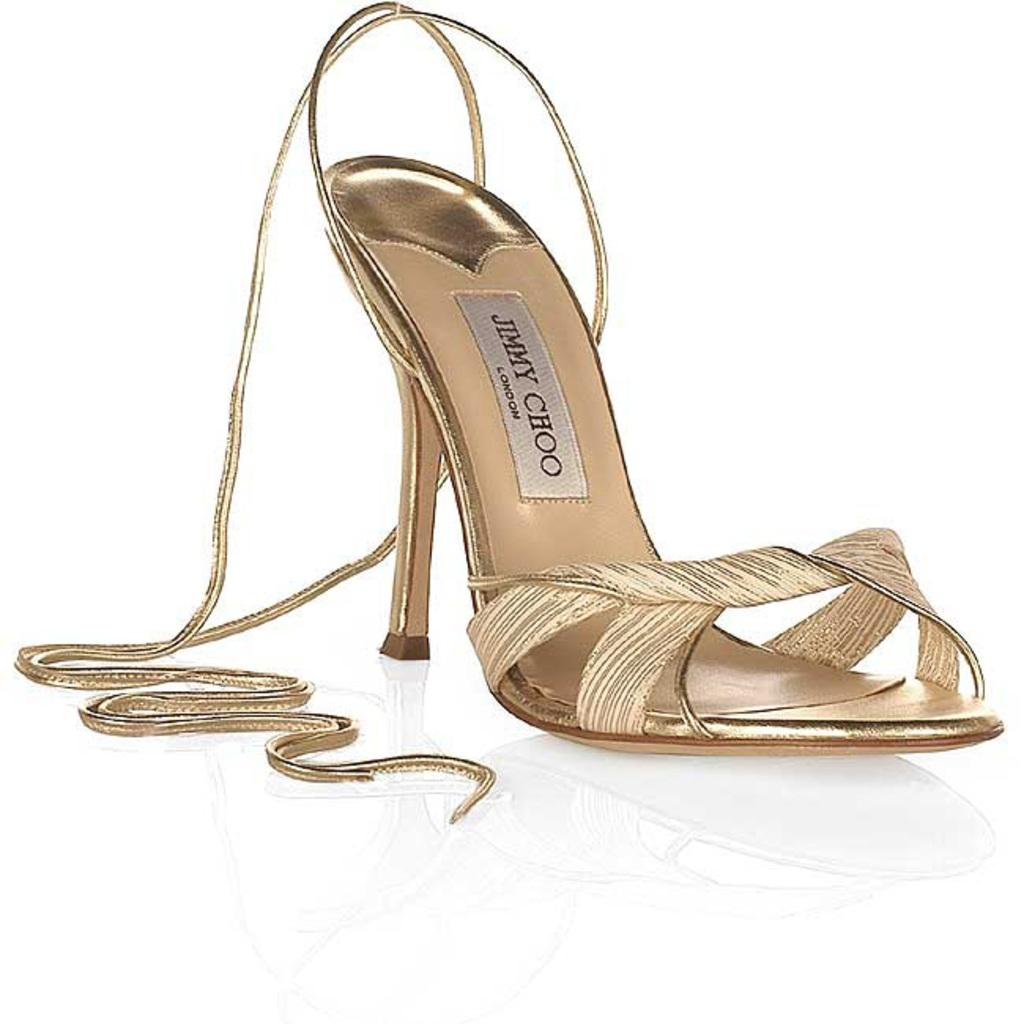What type of shoe is featured in the image? The image features a heel of a woman's shoe. What brand is the shoe? The heel has "Jimmy Choo" written on it, indicating that it is a Jimmy Choo shoe. What type of hat is the giraffe wearing in the image? There is no giraffe or hat present in the image; it only features a heel of a woman's shoe. 